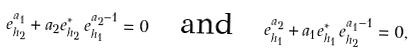<formula> <loc_0><loc_0><loc_500><loc_500>e _ { h _ { 2 } } ^ { a _ { 1 } } + a _ { 2 } e _ { h _ { 2 } } ^ { * } \, e _ { h _ { 1 } } ^ { a _ { 2 } - 1 } = 0 \quad \text {and} \quad e _ { h _ { 1 } } ^ { a _ { 2 } } + a _ { 1 } e _ { h _ { 1 } } ^ { * } \, e _ { h _ { 2 } } ^ { a _ { 1 } - 1 } = 0 ,</formula> 